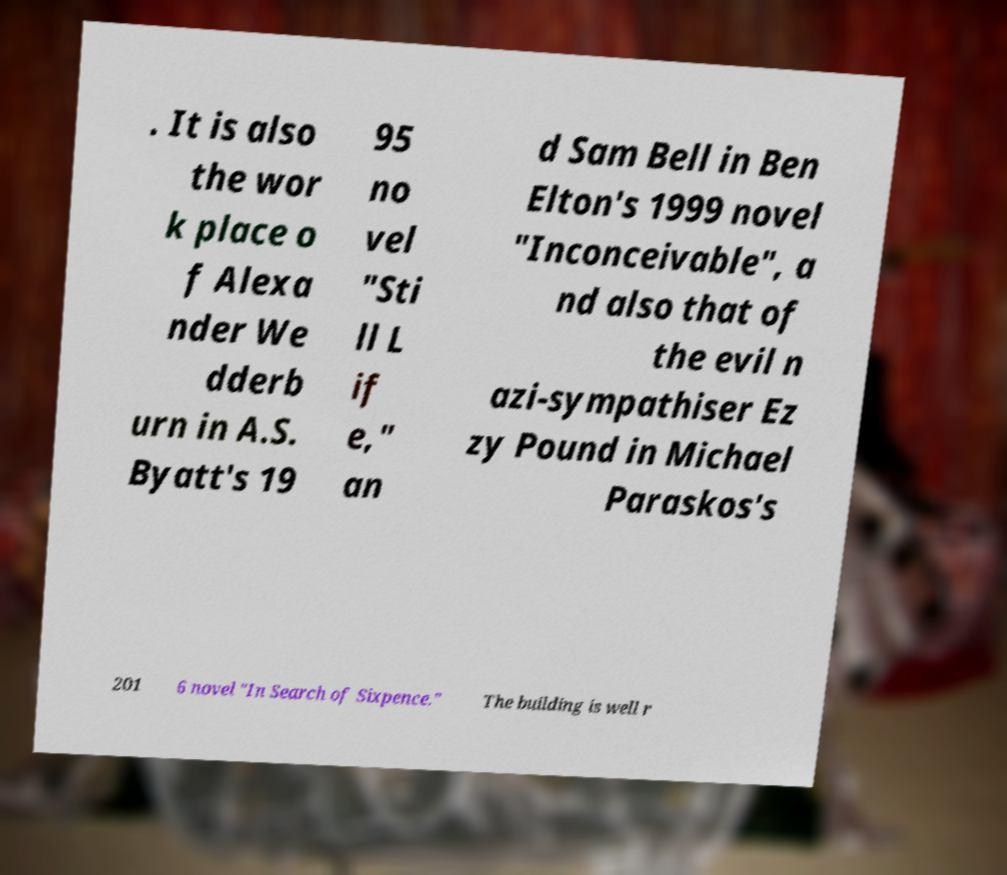I need the written content from this picture converted into text. Can you do that? . It is also the wor k place o f Alexa nder We dderb urn in A.S. Byatt's 19 95 no vel "Sti ll L if e," an d Sam Bell in Ben Elton's 1999 novel "Inconceivable", a nd also that of the evil n azi-sympathiser Ez zy Pound in Michael Paraskos's 201 6 novel "In Search of Sixpence." The building is well r 